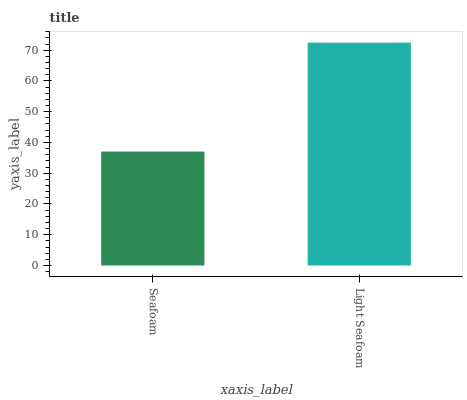Is Light Seafoam the maximum?
Answer yes or no. Yes. Is Light Seafoam the minimum?
Answer yes or no. No. Is Light Seafoam greater than Seafoam?
Answer yes or no. Yes. Is Seafoam less than Light Seafoam?
Answer yes or no. Yes. Is Seafoam greater than Light Seafoam?
Answer yes or no. No. Is Light Seafoam less than Seafoam?
Answer yes or no. No. Is Light Seafoam the high median?
Answer yes or no. Yes. Is Seafoam the low median?
Answer yes or no. Yes. Is Seafoam the high median?
Answer yes or no. No. Is Light Seafoam the low median?
Answer yes or no. No. 